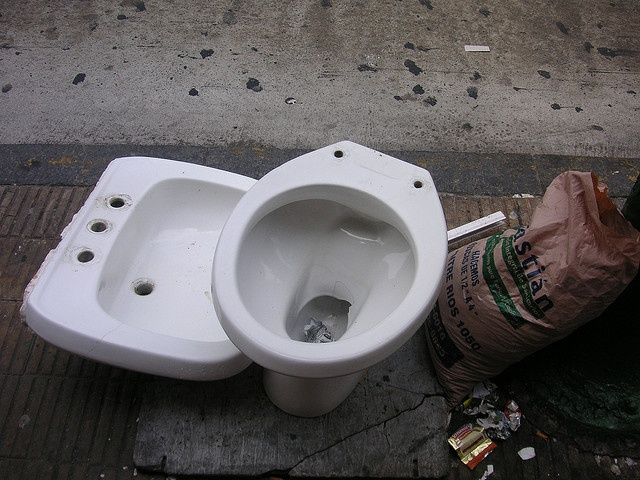Describe the objects in this image and their specific colors. I can see toilet in black, darkgray, lightgray, and gray tones and sink in black, lavender, darkgray, and gray tones in this image. 